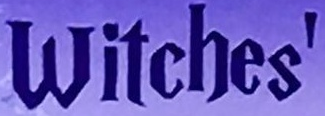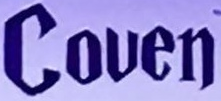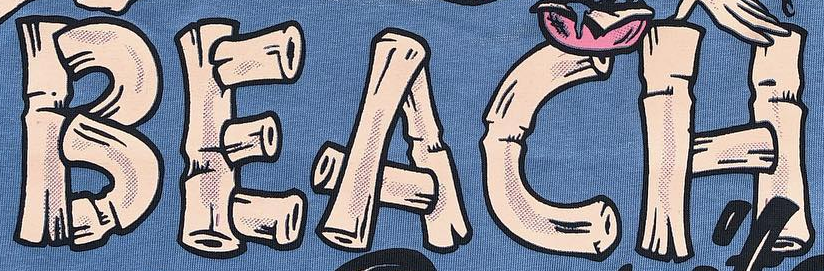What text appears in these images from left to right, separated by a semicolon? Witches'; Couen; BEACH 